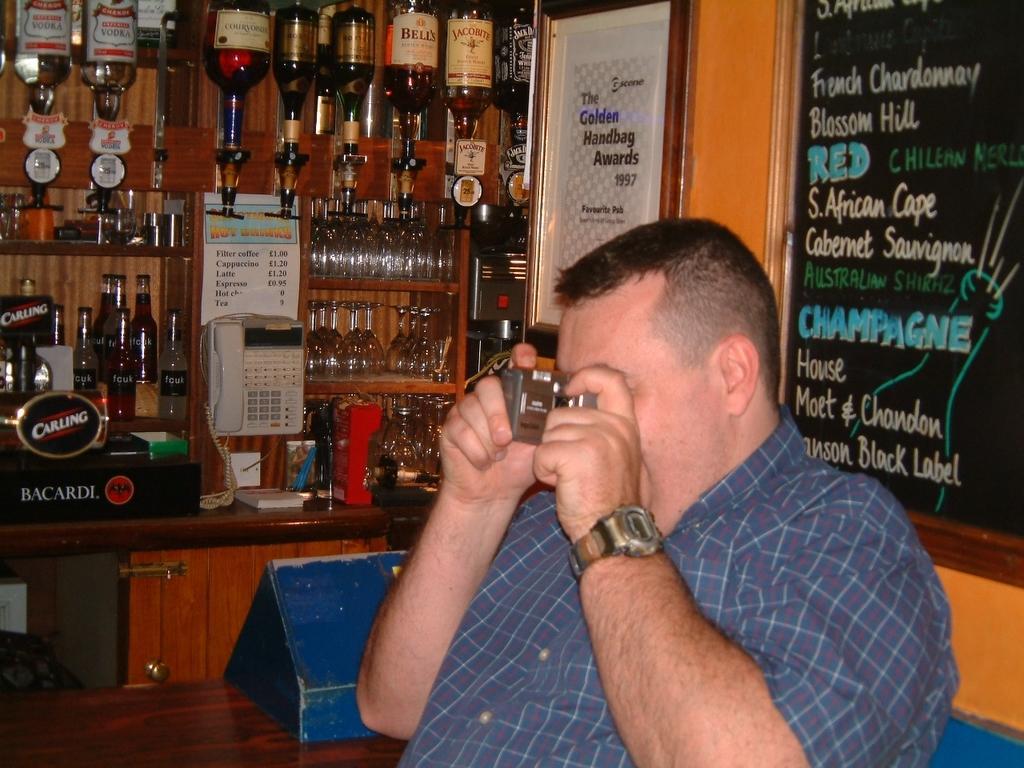Can you describe this image briefly? This picture describes about a man he is holding a camera, in the background we can see a notice board, couple of bottles, glasses and telephone. 